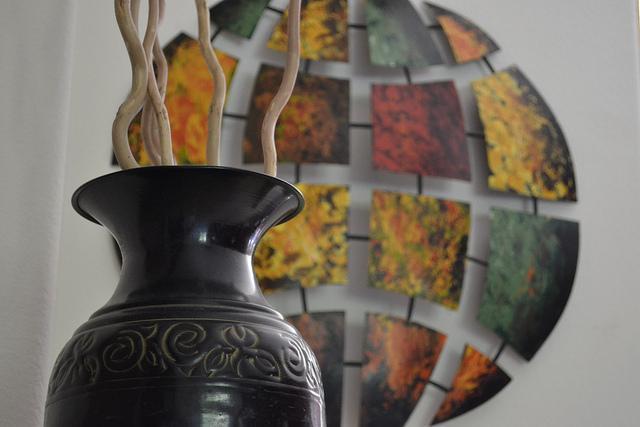How many orange lights are on the right side of the truck?
Give a very brief answer. 0. 